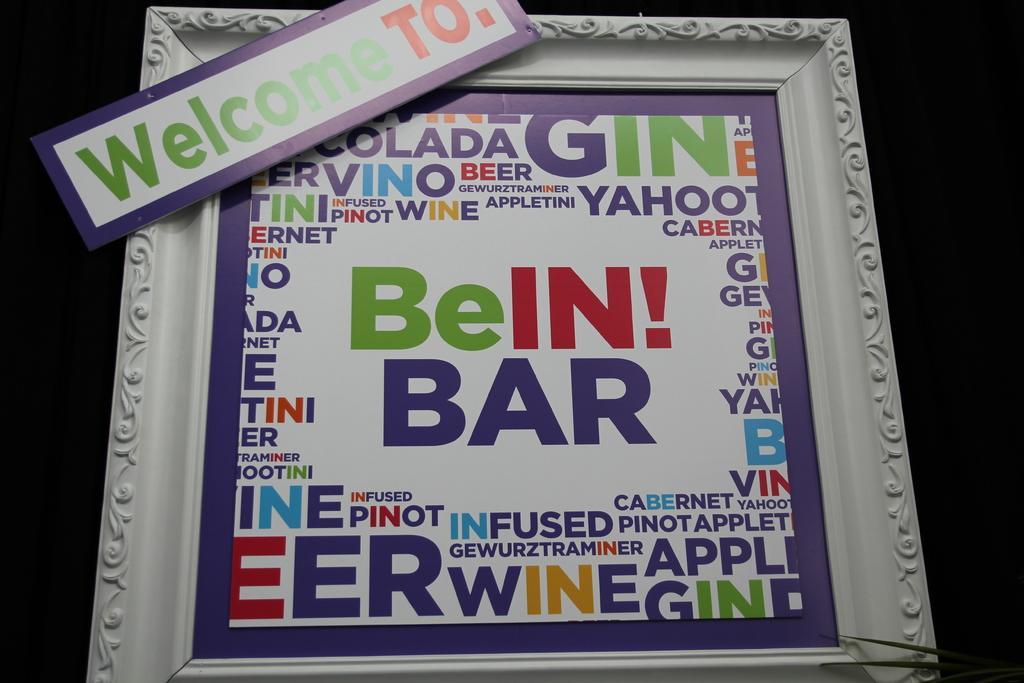<image>
Relay a brief, clear account of the picture shown. BeIN! BAR sign in a frame with words all around it 